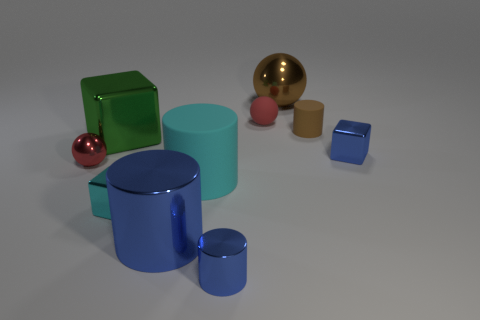What number of large spheres are in front of the tiny red thing that is in front of the big metal block?
Provide a short and direct response. 0. Does the small sphere that is in front of the small brown cylinder have the same color as the big matte cylinder?
Your response must be concise. No. How many things are either large blue objects or blue things on the right side of the big cyan matte cylinder?
Provide a succinct answer. 3. Does the shiny thing on the right side of the brown matte cylinder have the same shape as the big metal object in front of the cyan cylinder?
Your response must be concise. No. Is there anything else that has the same color as the big metal ball?
Offer a very short reply. Yes. What shape is the tiny cyan object that is made of the same material as the big brown sphere?
Offer a very short reply. Cube. The object that is both on the left side of the cyan matte cylinder and in front of the tiny cyan metallic cube is made of what material?
Provide a short and direct response. Metal. Do the matte sphere and the big shiny cube have the same color?
Keep it short and to the point. No. The matte thing that is the same color as the large metallic sphere is what shape?
Your answer should be very brief. Cylinder. What number of large blue metal objects are the same shape as the big rubber object?
Give a very brief answer. 1. 